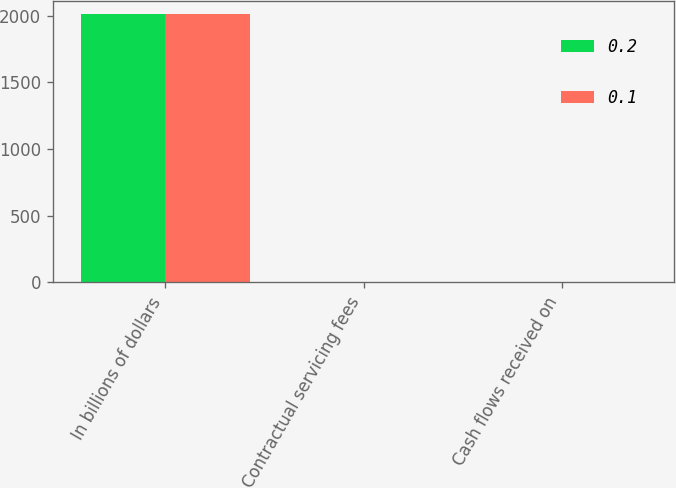<chart> <loc_0><loc_0><loc_500><loc_500><stacked_bar_chart><ecel><fcel>In billions of dollars<fcel>Contractual servicing fees<fcel>Cash flows received on<nl><fcel>0.2<fcel>2009<fcel>0.1<fcel>0.2<nl><fcel>0.1<fcel>2008<fcel>0.1<fcel>0.1<nl></chart> 